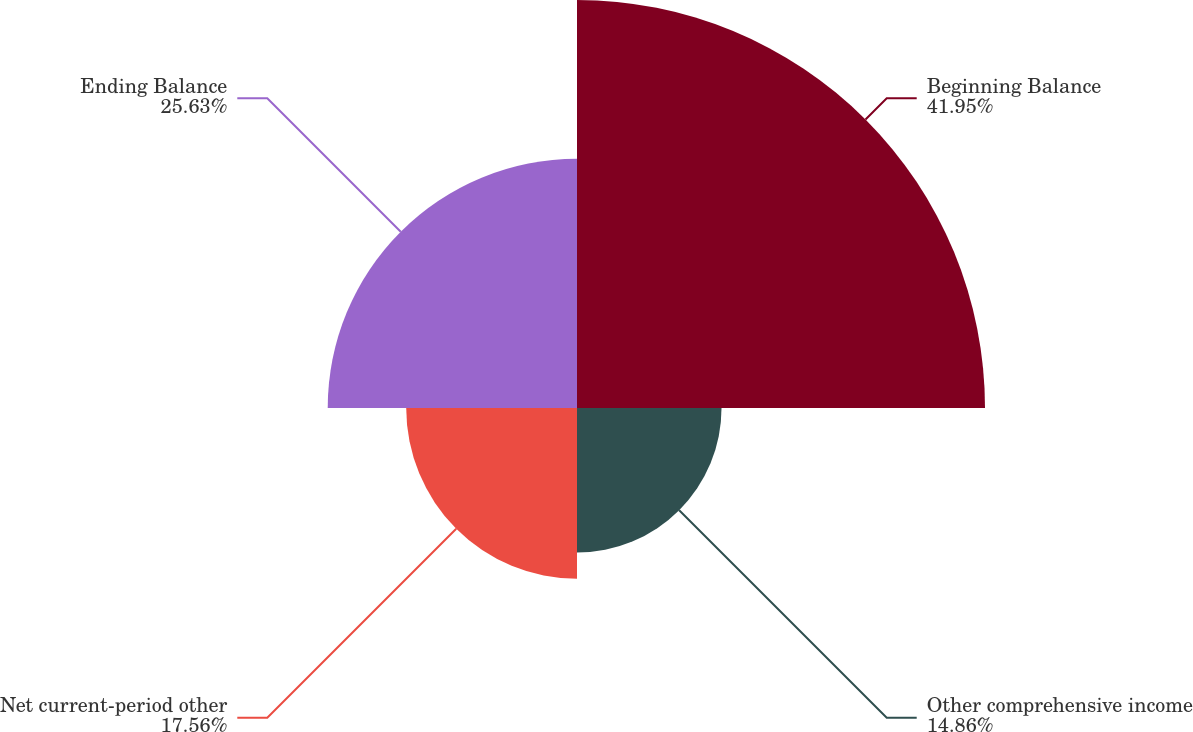Convert chart. <chart><loc_0><loc_0><loc_500><loc_500><pie_chart><fcel>Beginning Balance<fcel>Other comprehensive income<fcel>Net current-period other<fcel>Ending Balance<nl><fcel>41.95%<fcel>14.86%<fcel>17.56%<fcel>25.63%<nl></chart> 